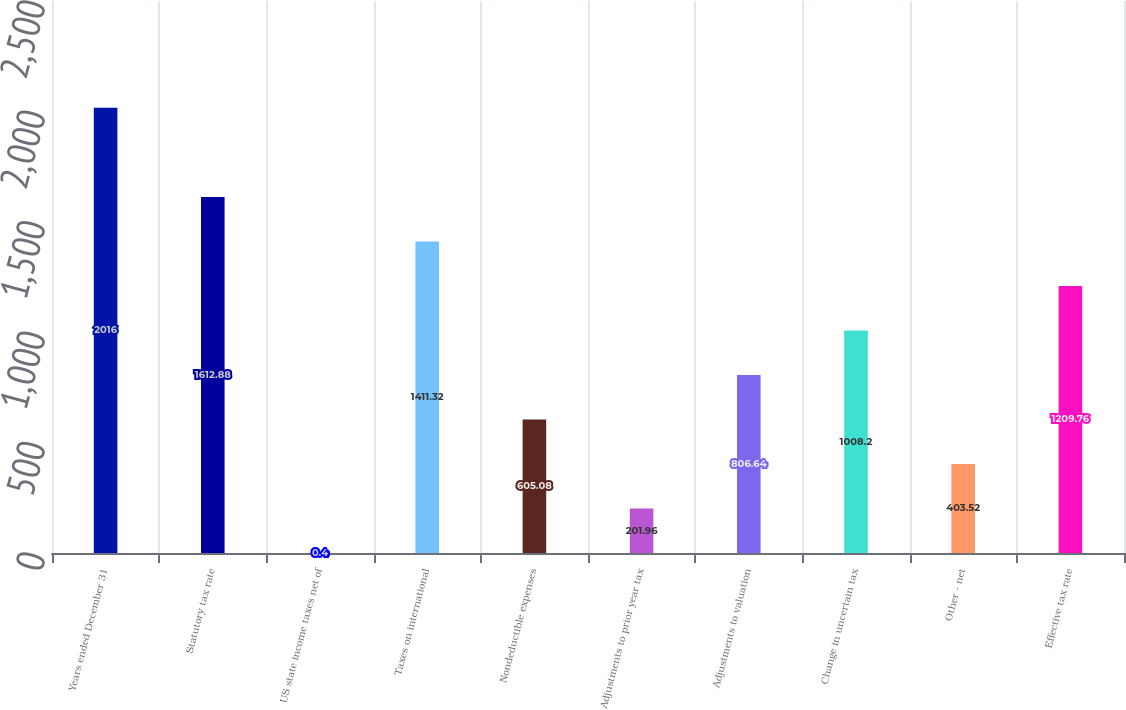<chart> <loc_0><loc_0><loc_500><loc_500><bar_chart><fcel>Years ended December 31<fcel>Statutory tax rate<fcel>US state income taxes net of<fcel>Taxes on international<fcel>Nondeductible expenses<fcel>Adjustments to prior year tax<fcel>Adjustments to valuation<fcel>Change in uncertain tax<fcel>Other - net<fcel>Effective tax rate<nl><fcel>2016<fcel>1612.88<fcel>0.4<fcel>1411.32<fcel>605.08<fcel>201.96<fcel>806.64<fcel>1008.2<fcel>403.52<fcel>1209.76<nl></chart> 